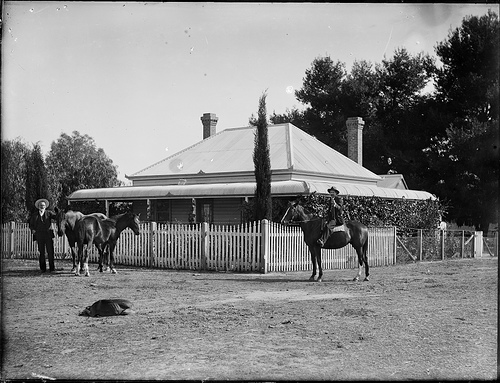Are there any people in the image? Yes, there are two individuals visible. One stands beside the horses to the left of the frame, holding onto one of the horse's reins. The other is mounted on the far right horse, suggesting a readiness for travel or work. What does the presence of the horses tell us about this place? The horses indicate that this place likely values equestrian activities, which could be essential for transportation, work on the land, or leisure. It also reflects a lifestyle that is closely connected with animals and nature. 